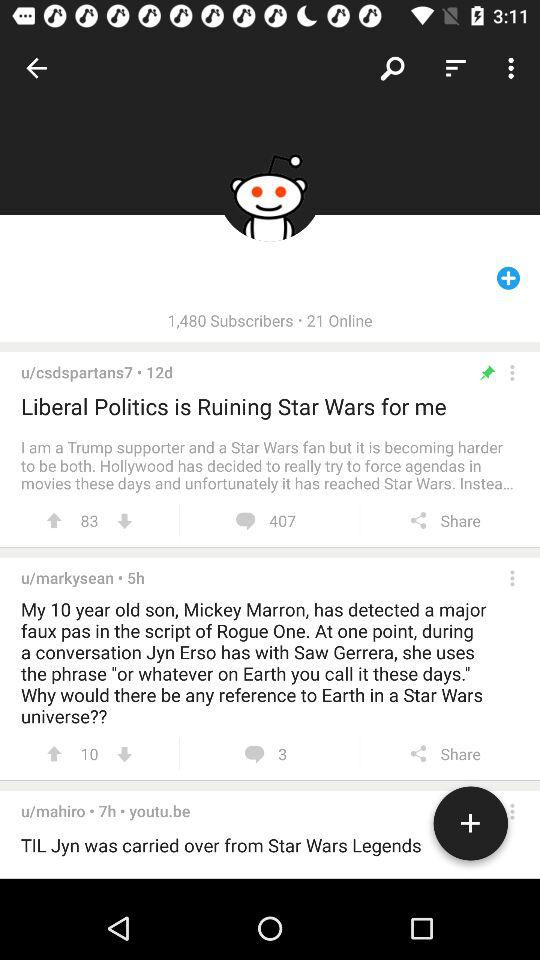When was the post on the "Liberal Politics" topic posted? The post was posted 12 days ago. 